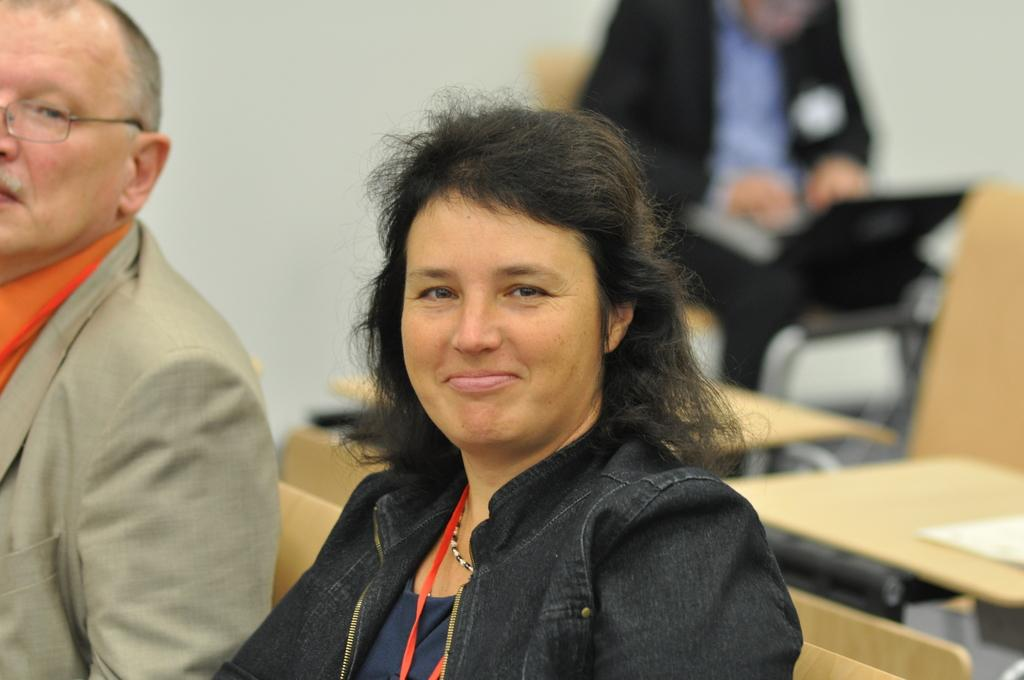How many people are in the image? There are two people in the image. What are the two people doing in the image? The two people are sitting on a chair. What type of design can be seen on the cable in the image? There is no cable present in the image, so it is not possible to answer that question. 